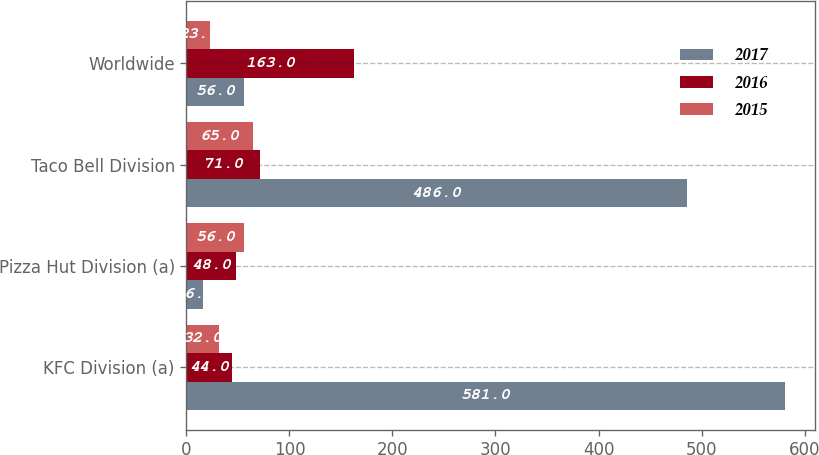Convert chart. <chart><loc_0><loc_0><loc_500><loc_500><stacked_bar_chart><ecel><fcel>KFC Division (a)<fcel>Pizza Hut Division (a)<fcel>Taco Bell Division<fcel>Worldwide<nl><fcel>2017<fcel>581<fcel>16<fcel>486<fcel>56<nl><fcel>2016<fcel>44<fcel>48<fcel>71<fcel>163<nl><fcel>2015<fcel>32<fcel>56<fcel>65<fcel>23<nl></chart> 